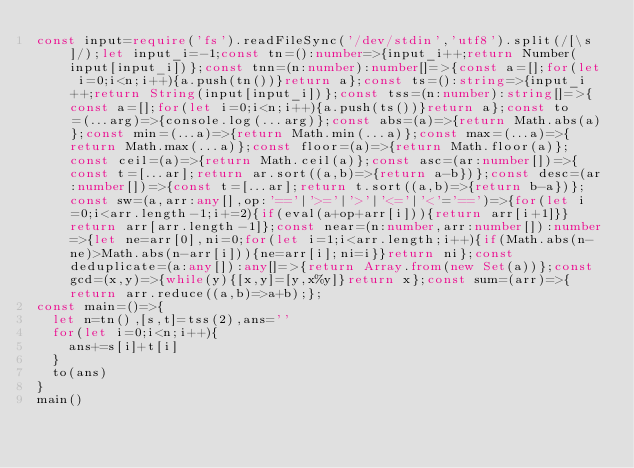Convert code to text. <code><loc_0><loc_0><loc_500><loc_500><_TypeScript_>const input=require('fs').readFileSync('/dev/stdin','utf8').split(/[\s]/);let input_i=-1;const tn=():number=>{input_i++;return Number(input[input_i])};const tnn=(n:number):number[]=>{const a=[];for(let i=0;i<n;i++){a.push(tn())}return a};const ts=():string=>{input_i++;return String(input[input_i])};const tss=(n:number):string[]=>{const a=[];for(let i=0;i<n;i++){a.push(ts())}return a};const to=(...arg)=>{console.log(...arg)};const abs=(a)=>{return Math.abs(a)};const min=(...a)=>{return Math.min(...a)};const max=(...a)=>{return Math.max(...a)};const floor=(a)=>{return Math.floor(a)};const ceil=(a)=>{return Math.ceil(a)};const asc=(ar:number[])=>{const t=[...ar];return ar.sort((a,b)=>{return a-b})};const desc=(ar:number[])=>{const t=[...ar];return t.sort((a,b)=>{return b-a})};const sw=(a,arr:any[],op:'=='|'>='|'>'|'<='|'<'='==')=>{for(let i=0;i<arr.length-1;i+=2){if(eval(a+op+arr[i])){return arr[i+1]}}return arr[arr.length-1]};const near=(n:number,arr:number[]):number=>{let ne=arr[0],ni=0;for(let i=1;i<arr.length;i++){if(Math.abs(n-ne)>Math.abs(n-arr[i])){ne=arr[i];ni=i}}return ni};const deduplicate=(a:any[]):any[]=>{return Array.from(new Set(a))};const gcd=(x,y)=>{while(y){[x,y]=[y,x%y]}return x};const sum=(arr)=>{return arr.reduce((a,b)=>a+b);};
const main=()=>{
  let n=tn(),[s,t]=tss(2),ans=''
  for(let i=0;i<n;i++){
    ans+=s[i]+t[i]
  }
  to(ans)
}
main()
</code> 